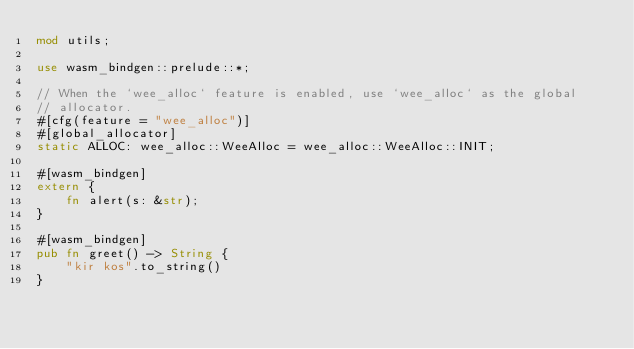Convert code to text. <code><loc_0><loc_0><loc_500><loc_500><_Rust_>mod utils;

use wasm_bindgen::prelude::*;

// When the `wee_alloc` feature is enabled, use `wee_alloc` as the global
// allocator.
#[cfg(feature = "wee_alloc")]
#[global_allocator]
static ALLOC: wee_alloc::WeeAlloc = wee_alloc::WeeAlloc::INIT;

#[wasm_bindgen]
extern {
    fn alert(s: &str);
}

#[wasm_bindgen]
pub fn greet() -> String {
    "kir kos".to_string()
}
</code> 